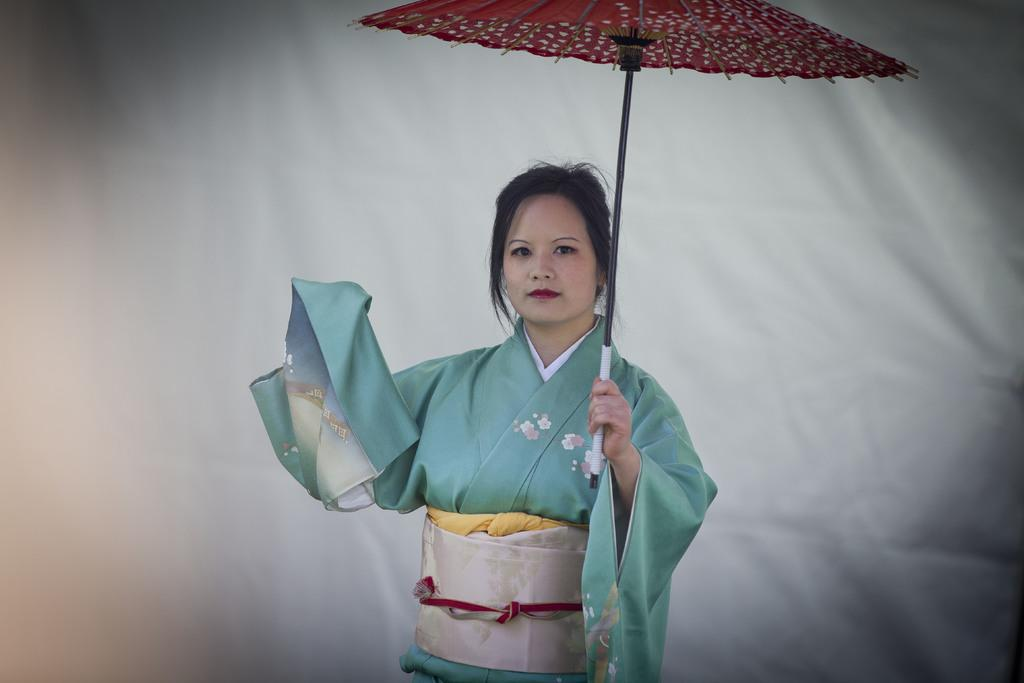Who is the main subject in the image? There is a lady in the image. What is the lady holding in the image? The lady is holding an umbrella. What is the color of the background in the image? The background of the image is white. What type of iron can be seen in the image? There is no iron present in the image. How does the lady show respect in the image? The image does not depict any actions or expressions that indicate respect, so it cannot be determined from the image. 